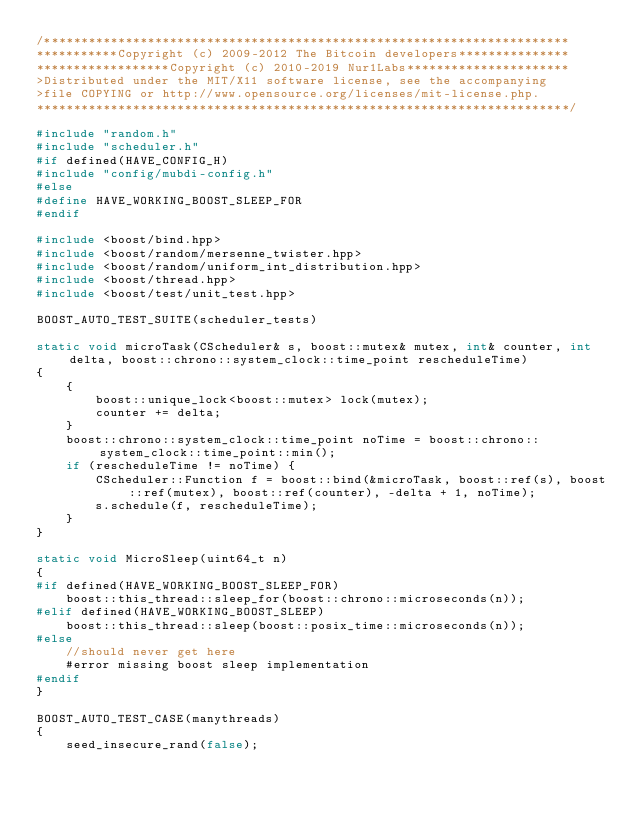Convert code to text. <code><loc_0><loc_0><loc_500><loc_500><_C++_>/***********************************************************************
***********Copyright (c) 2009-2012 The Bitcoin developers***************
******************Copyright (c) 2010-2019 Nur1Labs**********************
>Distributed under the MIT/X11 software license, see the accompanying
>file COPYING or http://www.opensource.org/licenses/mit-license.php.
************************************************************************/

#include "random.h"
#include "scheduler.h"
#if defined(HAVE_CONFIG_H)
#include "config/mubdi-config.h"
#else
#define HAVE_WORKING_BOOST_SLEEP_FOR
#endif

#include <boost/bind.hpp>
#include <boost/random/mersenne_twister.hpp>
#include <boost/random/uniform_int_distribution.hpp>
#include <boost/thread.hpp>
#include <boost/test/unit_test.hpp>

BOOST_AUTO_TEST_SUITE(scheduler_tests)

static void microTask(CScheduler& s, boost::mutex& mutex, int& counter, int delta, boost::chrono::system_clock::time_point rescheduleTime)
{
    {
        boost::unique_lock<boost::mutex> lock(mutex);
        counter += delta;
    }
    boost::chrono::system_clock::time_point noTime = boost::chrono::system_clock::time_point::min();
    if (rescheduleTime != noTime) {
        CScheduler::Function f = boost::bind(&microTask, boost::ref(s), boost::ref(mutex), boost::ref(counter), -delta + 1, noTime);
        s.schedule(f, rescheduleTime);
    }
}

static void MicroSleep(uint64_t n)
{
#if defined(HAVE_WORKING_BOOST_SLEEP_FOR)
    boost::this_thread::sleep_for(boost::chrono::microseconds(n));
#elif defined(HAVE_WORKING_BOOST_SLEEP)
    boost::this_thread::sleep(boost::posix_time::microseconds(n));
#else
    //should never get here
    #error missing boost sleep implementation
#endif
}

BOOST_AUTO_TEST_CASE(manythreads)
{
    seed_insecure_rand(false);
</code> 